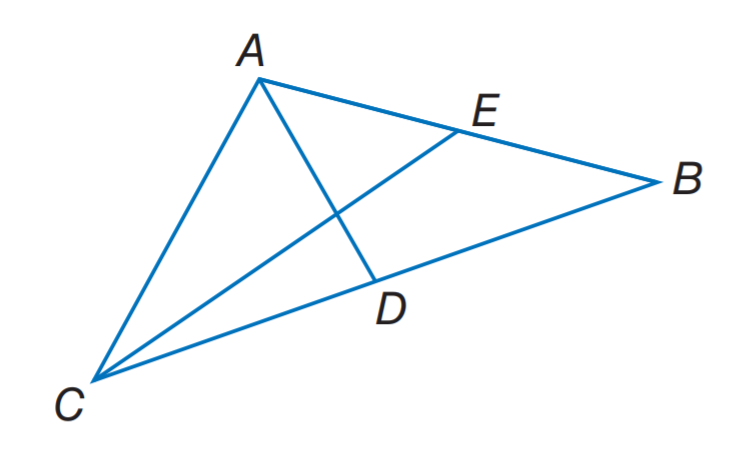Question: Segments A D and C E are medians of \triangle A C B, A D \perp C E, A B = 10, and C E = 9. Find C A.
Choices:
A. 2 \sqrt { 5 }
B. \sqrt { 41 }
C. \sqrt { 52 }
D. \sqrt { 61 }
Answer with the letter. Answer: C 